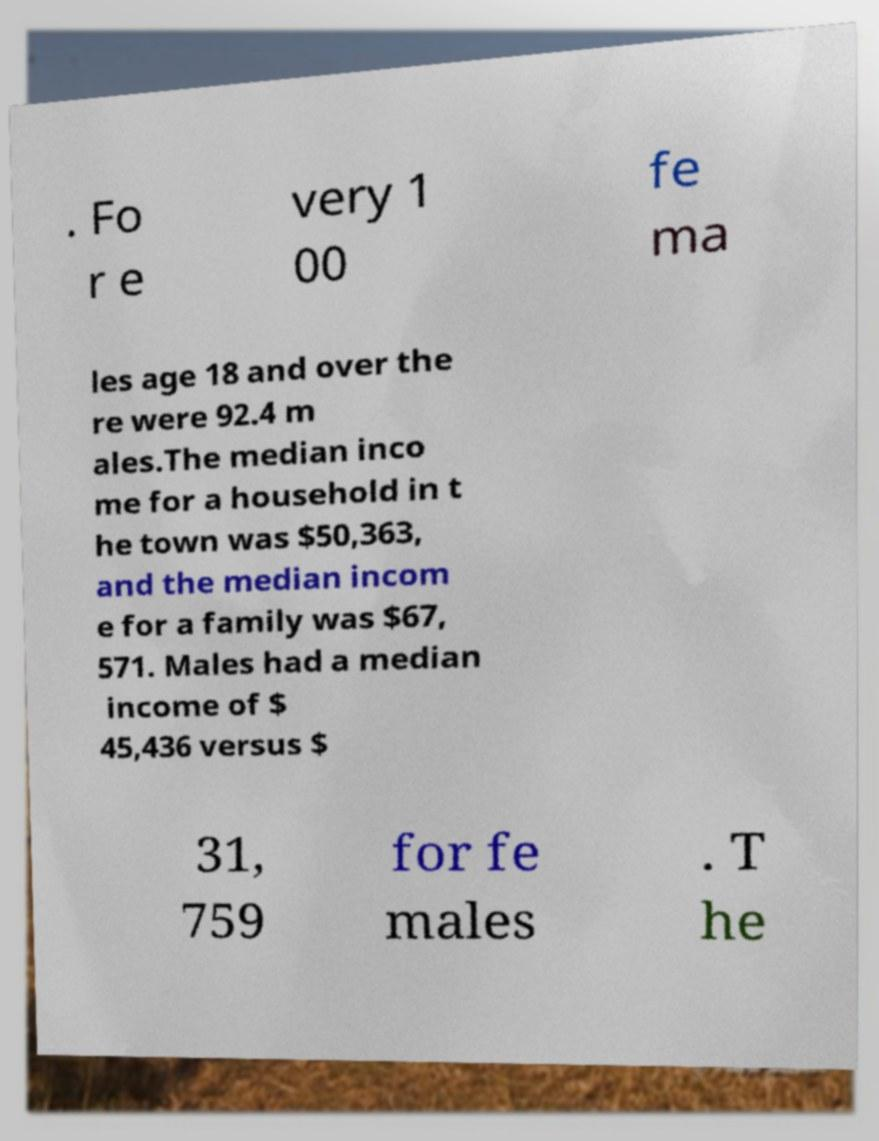I need the written content from this picture converted into text. Can you do that? . Fo r e very 1 00 fe ma les age 18 and over the re were 92.4 m ales.The median inco me for a household in t he town was $50,363, and the median incom e for a family was $67, 571. Males had a median income of $ 45,436 versus $ 31, 759 for fe males . T he 